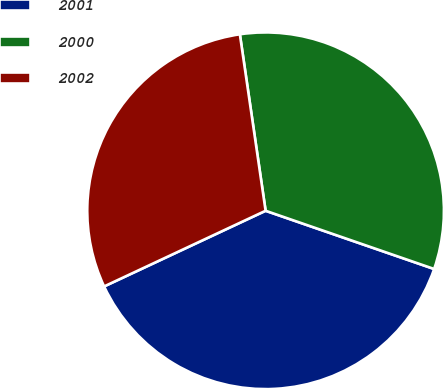<chart> <loc_0><loc_0><loc_500><loc_500><pie_chart><fcel>2001<fcel>2000<fcel>2002<nl><fcel>37.73%<fcel>32.6%<fcel>29.67%<nl></chart> 